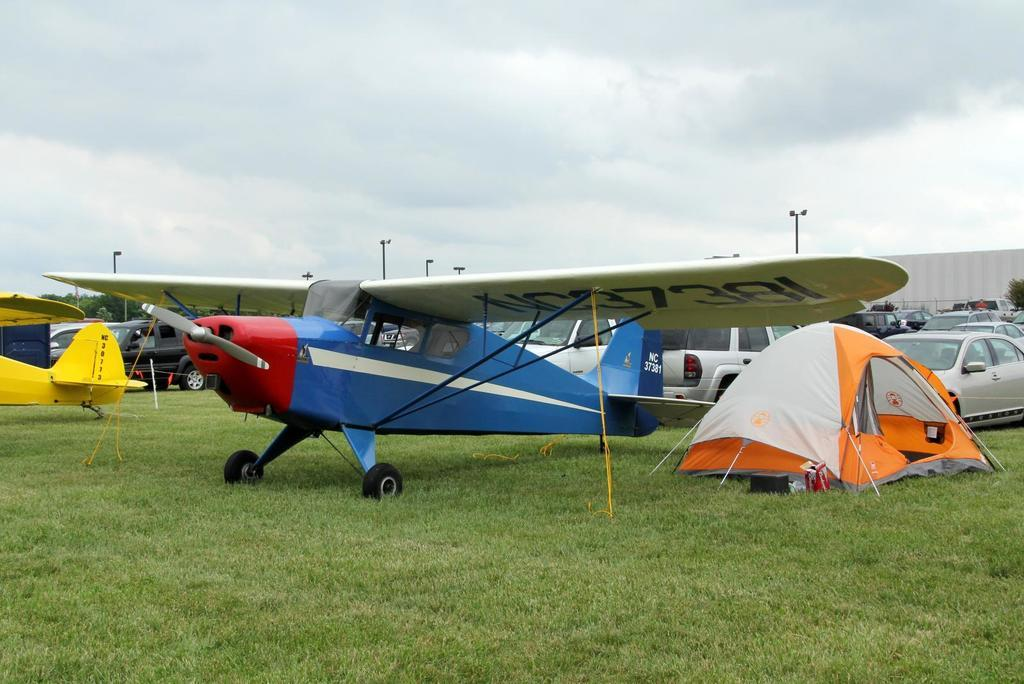What is the main subject in the center of the image? There are airplanes, tents, vehicles, boards, and poles in the center of the image. What type of structures can be seen in the center of the image? There are tents and boards in the center of the image. What type of transportation is visible in the center of the image? There are airplanes and vehicles in the center of the image. What type of objects can be seen in the center of the image? There are poles in the center of the image. What type of natural elements can be seen in the image? There are trees in the image. What is visible at the bottom of the image? The ground is visible at the bottom of the image. What is visible at the top of the image? The sky is visible at the top of the image. How much income does the donkey in the image earn? There is no donkey present in the image, so it is not possible to determine its income. Can you tell me how many times the person in the image jumps in the air? There is no person jumping in the air in the image, so it is not possible to determine how many times they jump. 